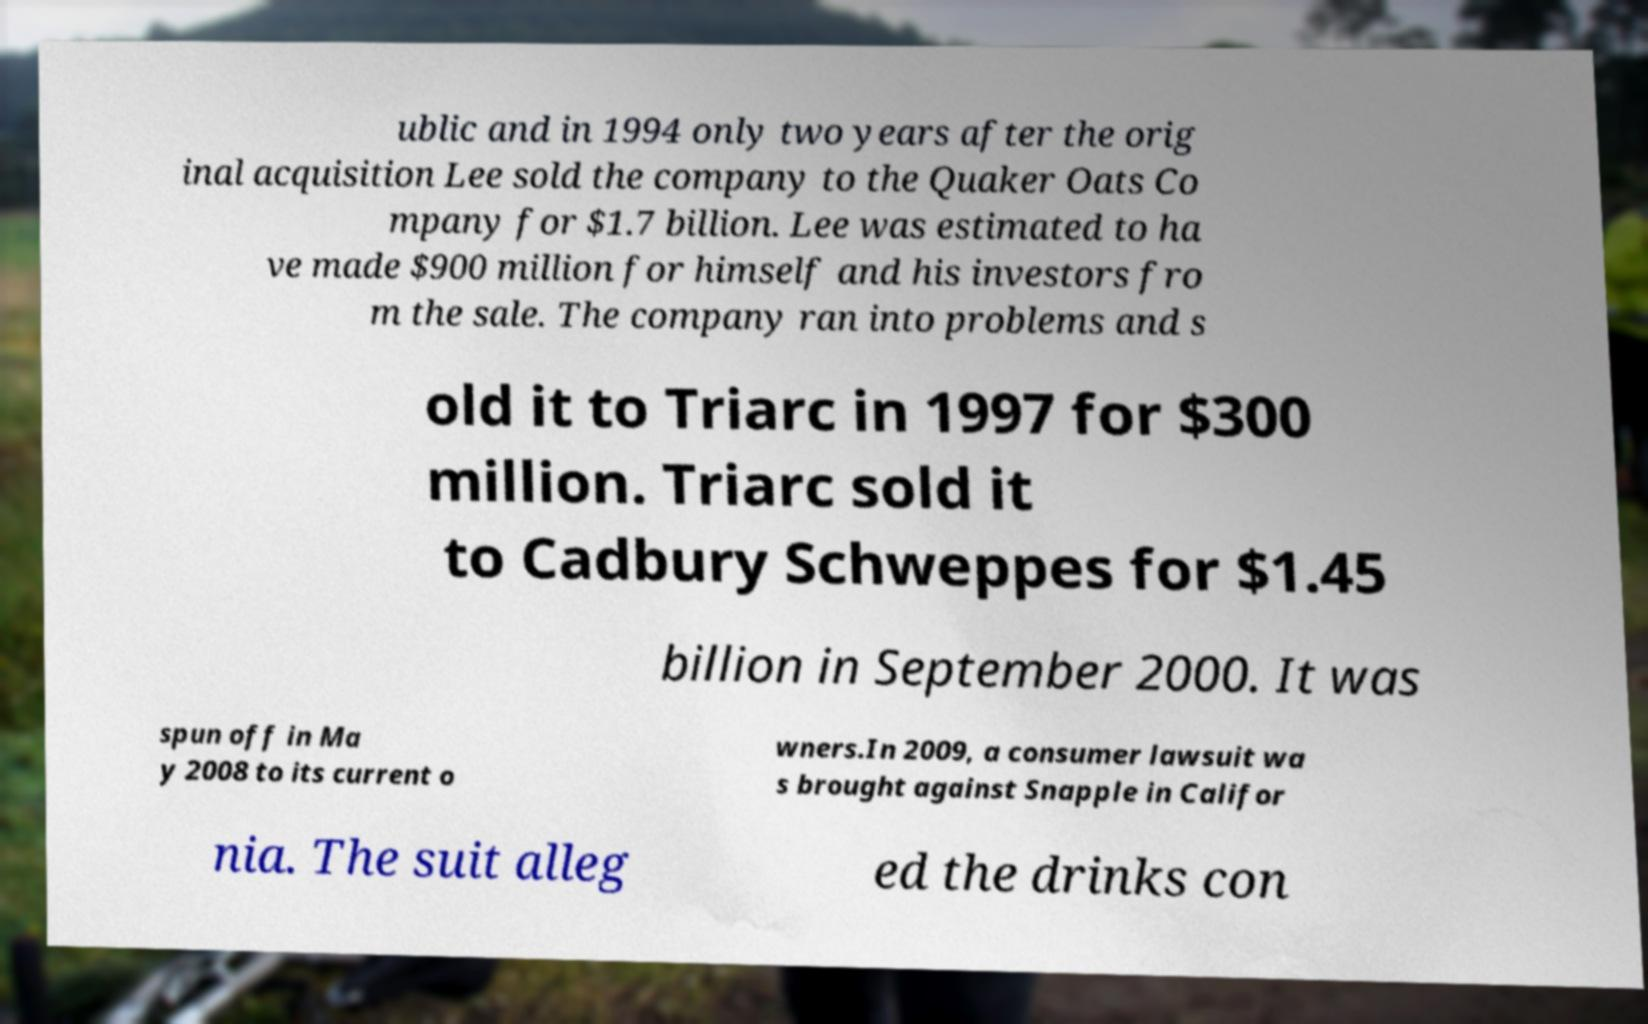Please read and relay the text visible in this image. What does it say? ublic and in 1994 only two years after the orig inal acquisition Lee sold the company to the Quaker Oats Co mpany for $1.7 billion. Lee was estimated to ha ve made $900 million for himself and his investors fro m the sale. The company ran into problems and s old it to Triarc in 1997 for $300 million. Triarc sold it to Cadbury Schweppes for $1.45 billion in September 2000. It was spun off in Ma y 2008 to its current o wners.In 2009, a consumer lawsuit wa s brought against Snapple in Califor nia. The suit alleg ed the drinks con 